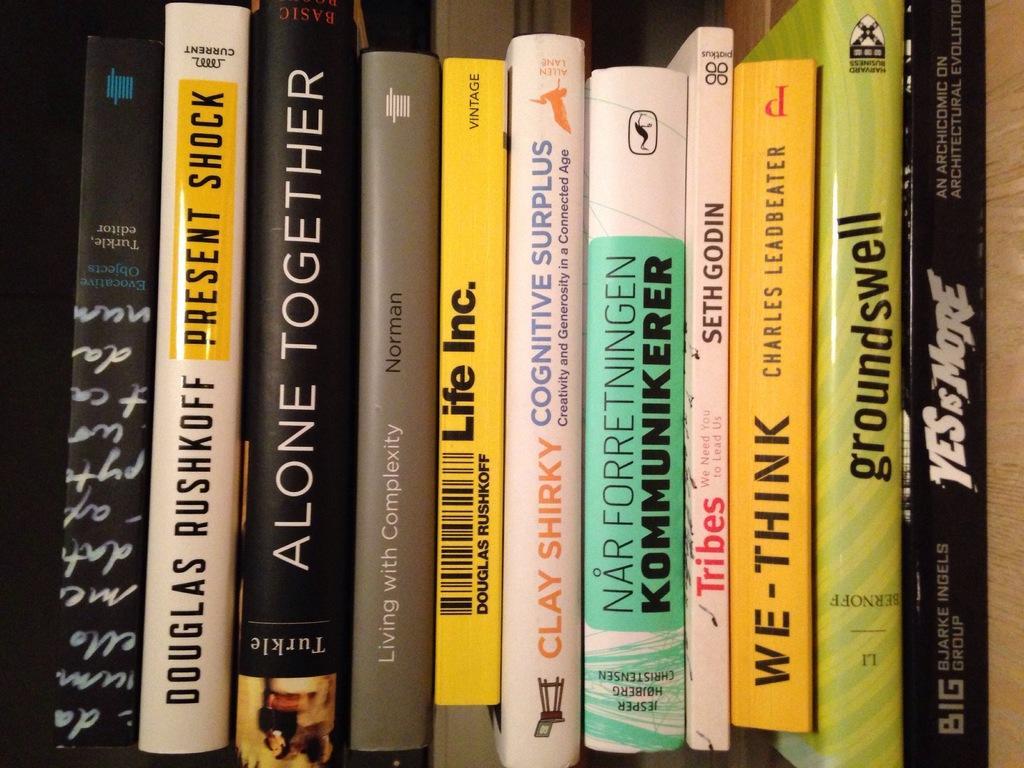Can you describe this image briefly? In this picture I can observe some books placed in the bookshelf. There are black, brown, yellow, white and green color books in this shelf. I can observe some text on these books. 